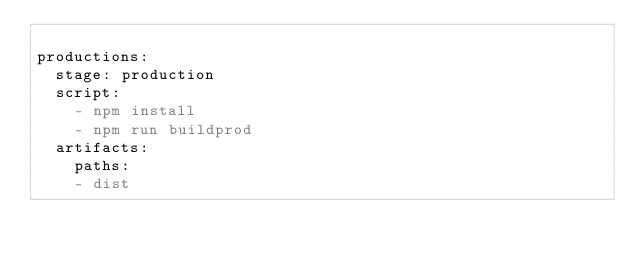<code> <loc_0><loc_0><loc_500><loc_500><_YAML_>  
productions:
  stage: production
  script: 
    - npm install
    - npm run buildprod
  artifacts:
    paths:
    - dist</code> 